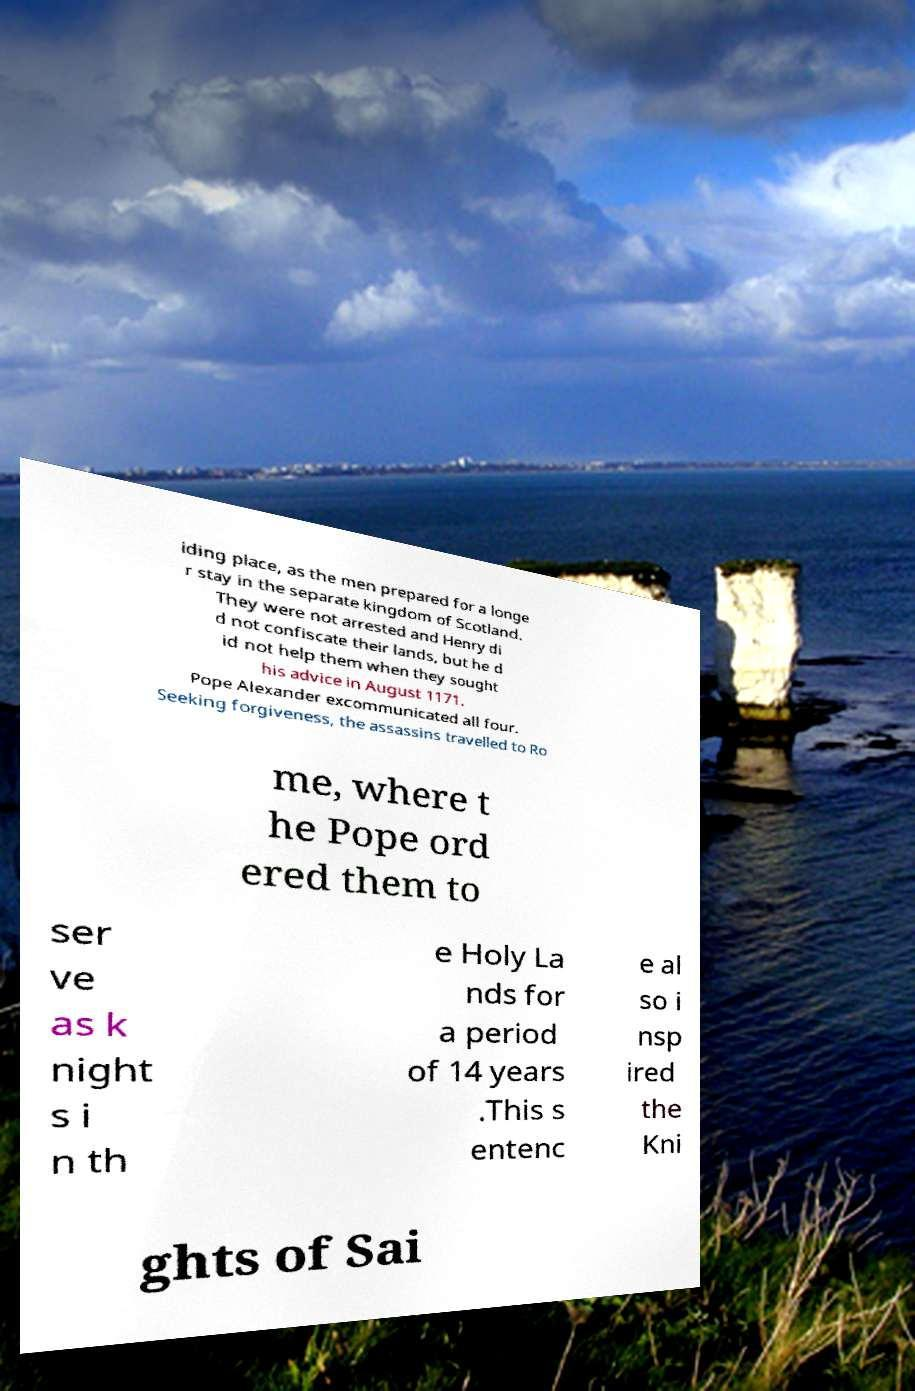Could you extract and type out the text from this image? iding place, as the men prepared for a longe r stay in the separate kingdom of Scotland. They were not arrested and Henry di d not confiscate their lands, but he d id not help them when they sought his advice in August 1171. Pope Alexander excommunicated all four. Seeking forgiveness, the assassins travelled to Ro me, where t he Pope ord ered them to ser ve as k night s i n th e Holy La nds for a period of 14 years .This s entenc e al so i nsp ired the Kni ghts of Sai 